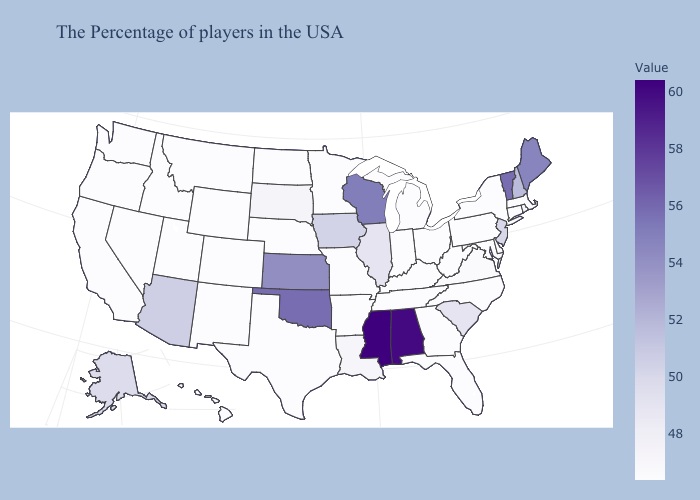Does West Virginia have the highest value in the South?
Concise answer only. No. Which states have the highest value in the USA?
Short answer required. Mississippi. Is the legend a continuous bar?
Keep it brief. Yes. 